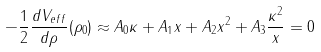<formula> <loc_0><loc_0><loc_500><loc_500>- \frac { 1 } { 2 } \frac { d V _ { e f f } } { d \rho } ( \rho _ { 0 } ) \approx A _ { 0 } \kappa + A _ { 1 } x + A _ { 2 } x ^ { 2 } + A _ { 3 } \frac { \kappa ^ { 2 } } { x } = 0</formula> 